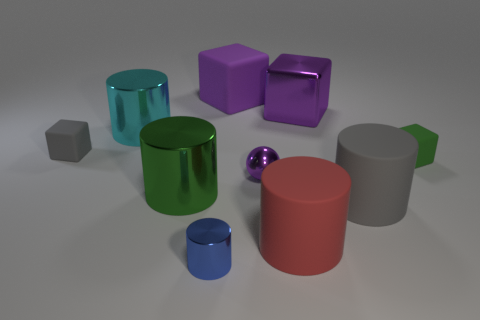Subtract all blue cylinders. How many cylinders are left? 4 Subtract all green shiny cylinders. How many cylinders are left? 4 Subtract all yellow cylinders. Subtract all gray balls. How many cylinders are left? 5 Subtract all balls. How many objects are left? 9 Subtract all large blue metal cylinders. Subtract all small purple metal balls. How many objects are left? 9 Add 9 tiny blue metal cylinders. How many tiny blue metal cylinders are left? 10 Add 4 tiny yellow metallic objects. How many tiny yellow metallic objects exist? 4 Subtract 1 green cylinders. How many objects are left? 9 